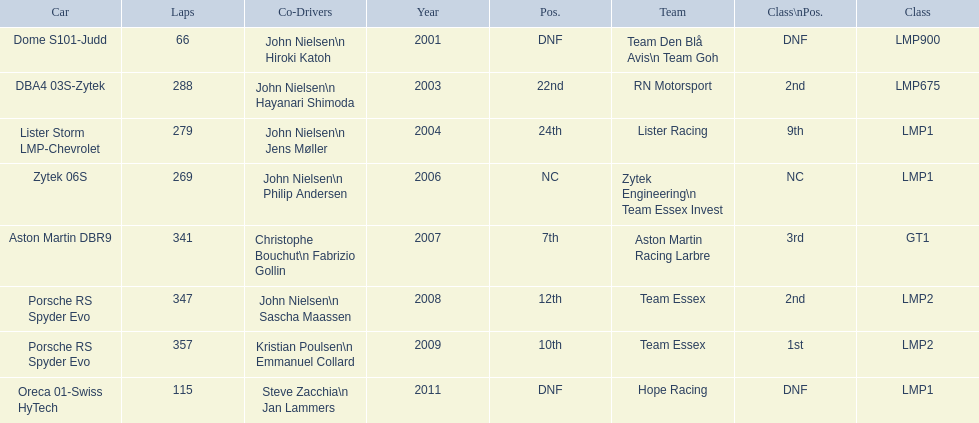In 2008 and what other year was casper elgaard on team essex for the 24 hours of le mans? 2009. 